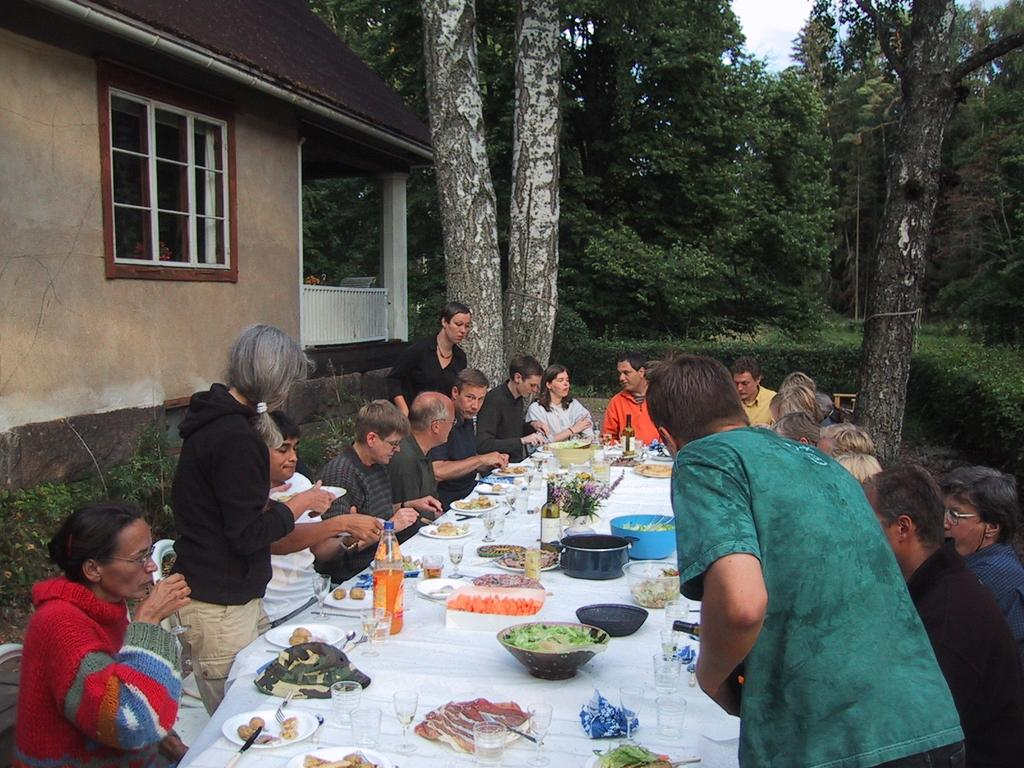What are the people in the image doing? The people in the image are sitting around a table and having food. Are there any other people visible in the image? Yes, there are three people standing beside the seated group. What can be seen in the background of the image? There are trees and a house in the background of the image. What type of chicken is being served to the people in the image? There is no chicken visible in the image; the people are having food, but the specific type of food is not mentioned. What songs are being sung by the people in the image? There is no indication in the image that the people are singing songs. 